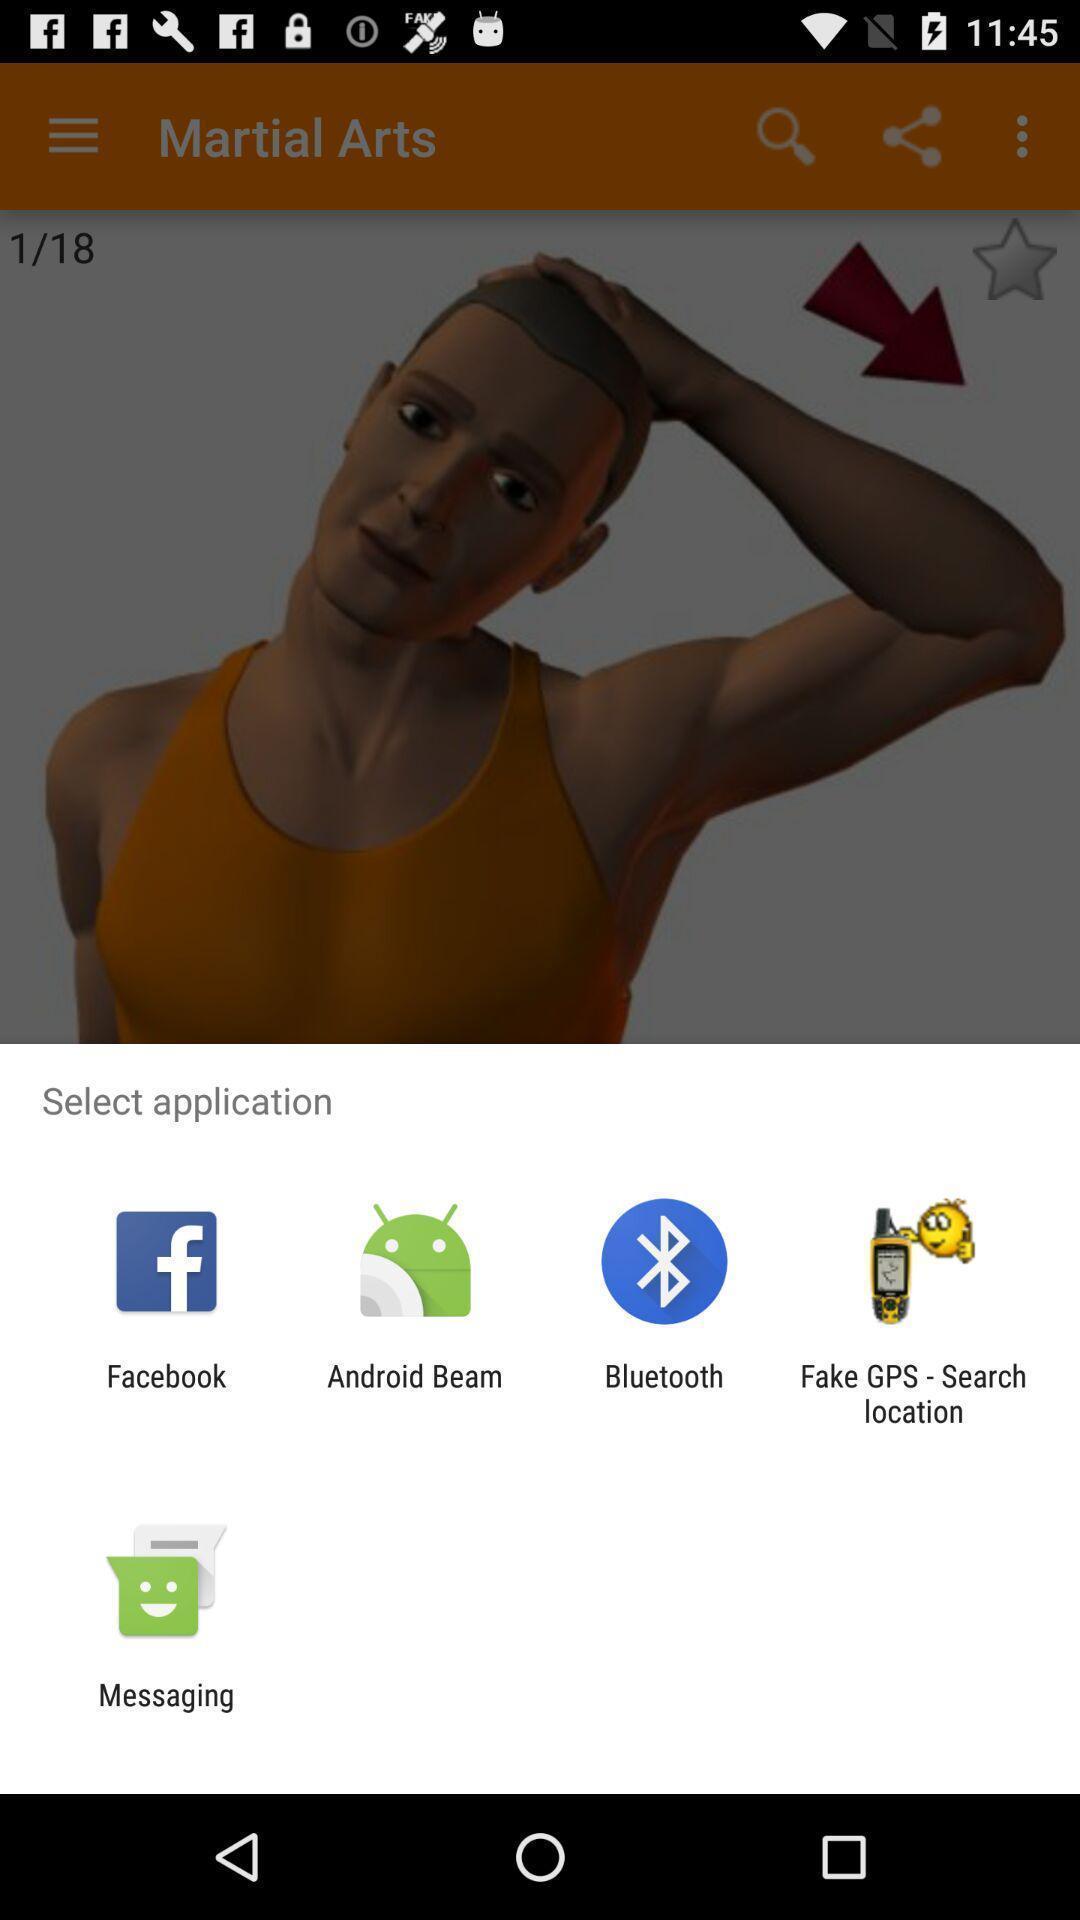Explain the elements present in this screenshot. Share information to select application. 